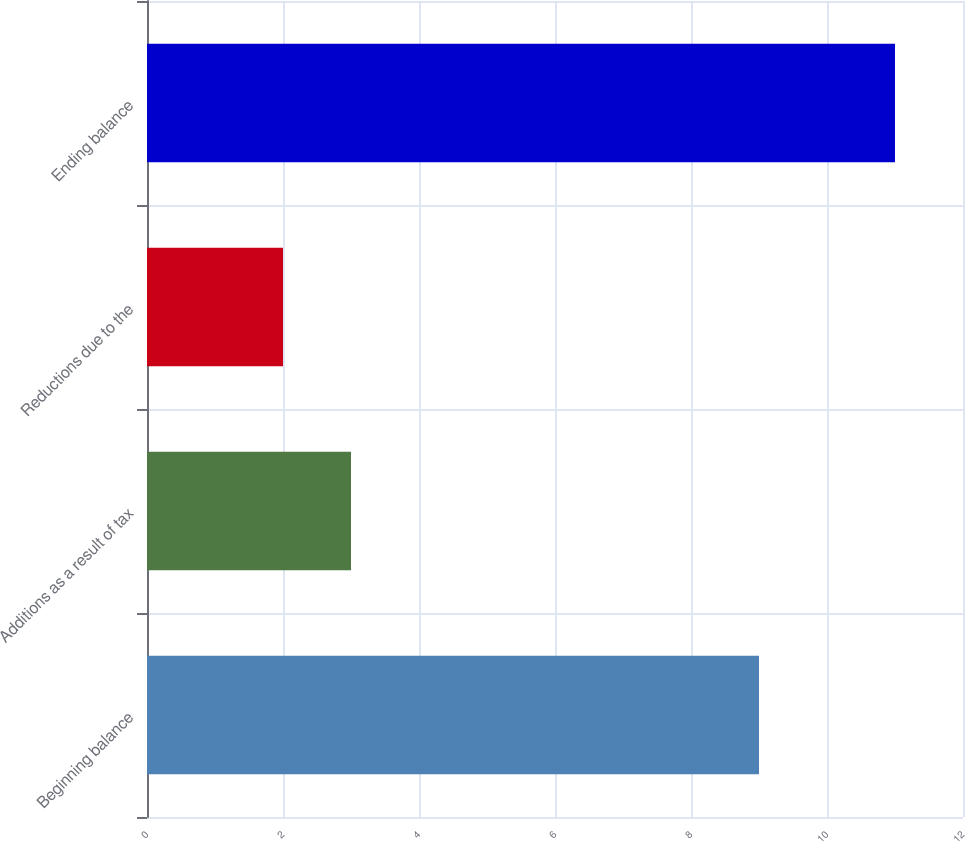<chart> <loc_0><loc_0><loc_500><loc_500><bar_chart><fcel>Beginning balance<fcel>Additions as a result of tax<fcel>Reductions due to the<fcel>Ending balance<nl><fcel>9<fcel>3<fcel>2<fcel>11<nl></chart> 